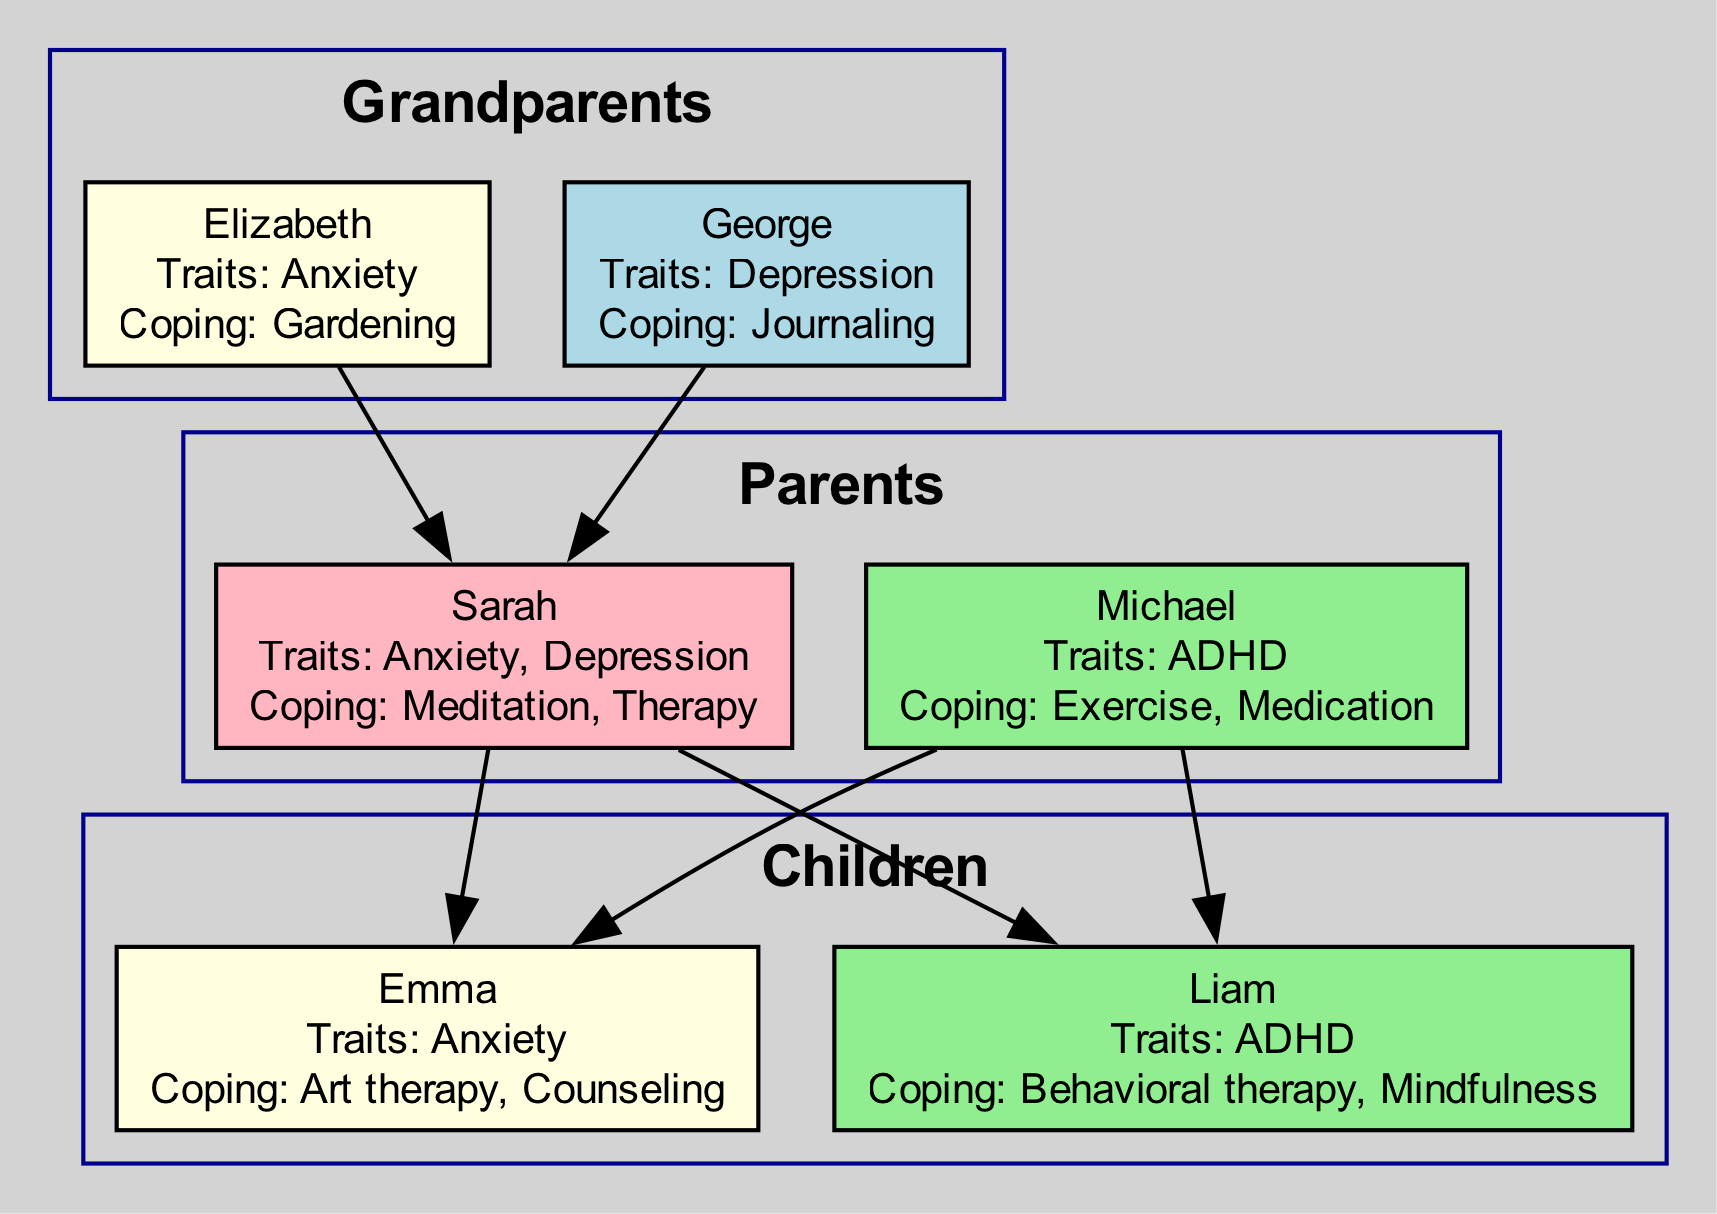What traits does Sarah inherit from her parents? To find the traits Sarah inherits, we look at her parents' traits. Both Elizabeth has Anxiety and George has Depression. Since Sarah's traits are listed as Anxiety and Depression, it shows she inherited both of these from her parents.
Answer: Anxiety, Depression How many members are in the "Children" generation? The "Children" generation contains two members: Emma and Liam. Thus, counting them gives us a total of two members.
Answer: 2 What coping mechanism does Michael use? Michael's coping mechanism is listed directly next to his name in the diagram. It states that he uses Exercise and Medication as his coping strategy.
Answer: Exercise, Medication Which family member utilizes art therapy? Looking at the list of coping mechanisms, Emma is the member who uses art therapy. This is clearly mentioned under her name in the diagram.
Answer: Emma Which grandparent's trait is associated with gardening? The diagram shows that Elizabeth has Anxiety and her coping mechanism is Gardening. Thus, the trait associated with gardening belongs to Elizabeth.
Answer: Elizabeth What relationship does Liam have with Michael? To determine the relationship, we look at the diagram, which shows that Liam is a child of Michael. This direct connection indicates that Michael is Liam's father.
Answer: Father How many traits does Sarah have? To find the number of traits Sarah has, we directly refer to her information in the diagram, which lists her traits as Anxiety and Depression. Thus, she has two traits.
Answer: 2 What coping mechanism is used for Emma's anxiety? Emma's coping mechanism and its association with her anxiety are indicated in the diagram. It states she uses art therapy and counseling. Therefore, the coping mechanism associated with her anxiety is art therapy.
Answer: Art therapy What mental health trait do both Emma and Liam share? By examining the traits listed for Emma and Liam, we see that Emma has Anxiety and Liam has ADHD. Therefore, they do not share any mental health traits. Hence, the answer is that there are none.
Answer: None 